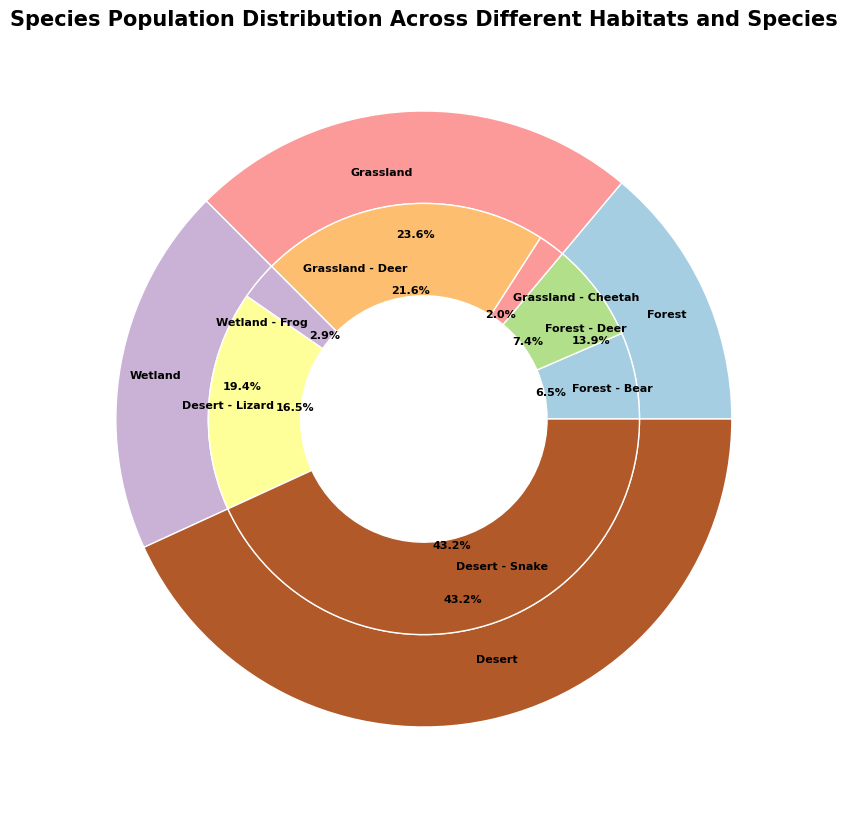What's the most populous species in the Forest habitat? Look at the inner ring sections corresponding to the Forest habitat and compare their population sizes. The largest section will indicate the most populous species.
Answer: Deer Which habitat has the highest total population? Look at the outer ring sections and identify the largest one by size or percentage.
Answer: Wetland How many adult male snakes are there in the Desert habitat? Find the section of the inner ring corresponding to adult male snakes in the Desert habitat and read the population number.
Answer: 70 Compare the number of juvenile female cheetahs to juvenile male cheetahs in the Grassland habitat. Which is higher? Locate the sections for juvenile female cheetahs and juvenile male cheetahs in the Grassland habitat in the inner ring and compare their population numbers.
Answer: Male cheetahs Calculate the total population of adult frogs in the Wetland habitat. Find the sections for adult male and female frogs in the Wetland habitat in the inner ring and sum their populations: 400 (male) + 390 (female).
Answer: 790 Is the population of juvenile female lizards in the Desert habitat higher or lower than the population of juvenile male snakes in the same habitat? Compare the sections for juvenile female lizards and juvenile male snakes in the Desert habitat in the inner ring.
Answer: Higher What's the percentage difference between the total deer population in the Forest habitat and the Grassland habitat? First, sum the deer populations in the Forest (120+110+230+240) and Grassland (95+90+180+170) habitats. Then calculate the percentage difference between the two sums.
Answer: 15.2% Which sex has a higher population of adult cheetahs in the Grassland habitat? Compare the inner ring sections for adult male and female cheetahs in the Grassland habitat.
Answer: Male How many species are represented in the Forest habitat, and what are they? Count and list all unique species sections within the Forest habitat in the inner ring.
Answer: 2; Deer and Bear Compare the total population of juvenile frogs to adult frogs in the Wetland habitat. Which is higher? Sum the populations of juvenile frogs (300+310) and adult frogs (400+390) in the Wetland habitat and compare the totals.
Answer: Adult frogs 